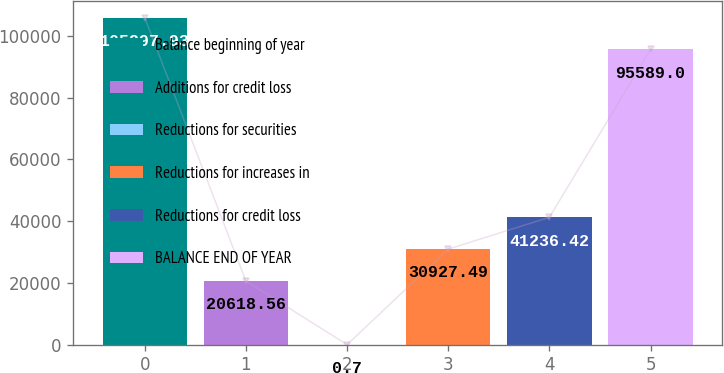Convert chart to OTSL. <chart><loc_0><loc_0><loc_500><loc_500><bar_chart><fcel>Balance beginning of year<fcel>Additions for credit loss<fcel>Reductions for securities<fcel>Reductions for increases in<fcel>Reductions for credit loss<fcel>BALANCE END OF YEAR<nl><fcel>105898<fcel>20618.6<fcel>0.7<fcel>30927.5<fcel>41236.4<fcel>95589<nl></chart> 